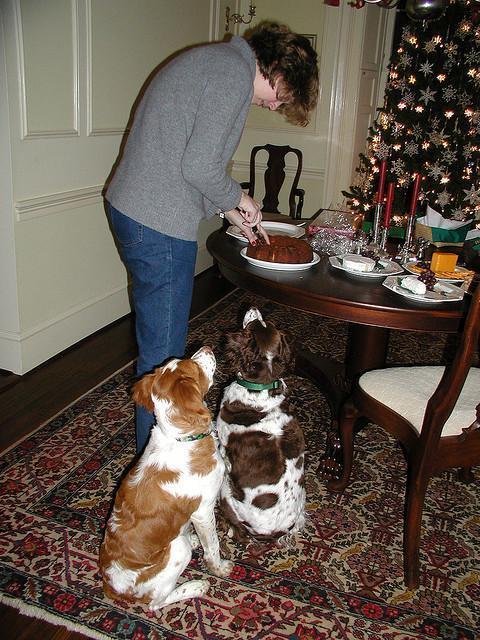How many dogs are there?
Give a very brief answer. 2. How many chairs are there?
Give a very brief answer. 2. How many dogs are visible?
Give a very brief answer. 2. 